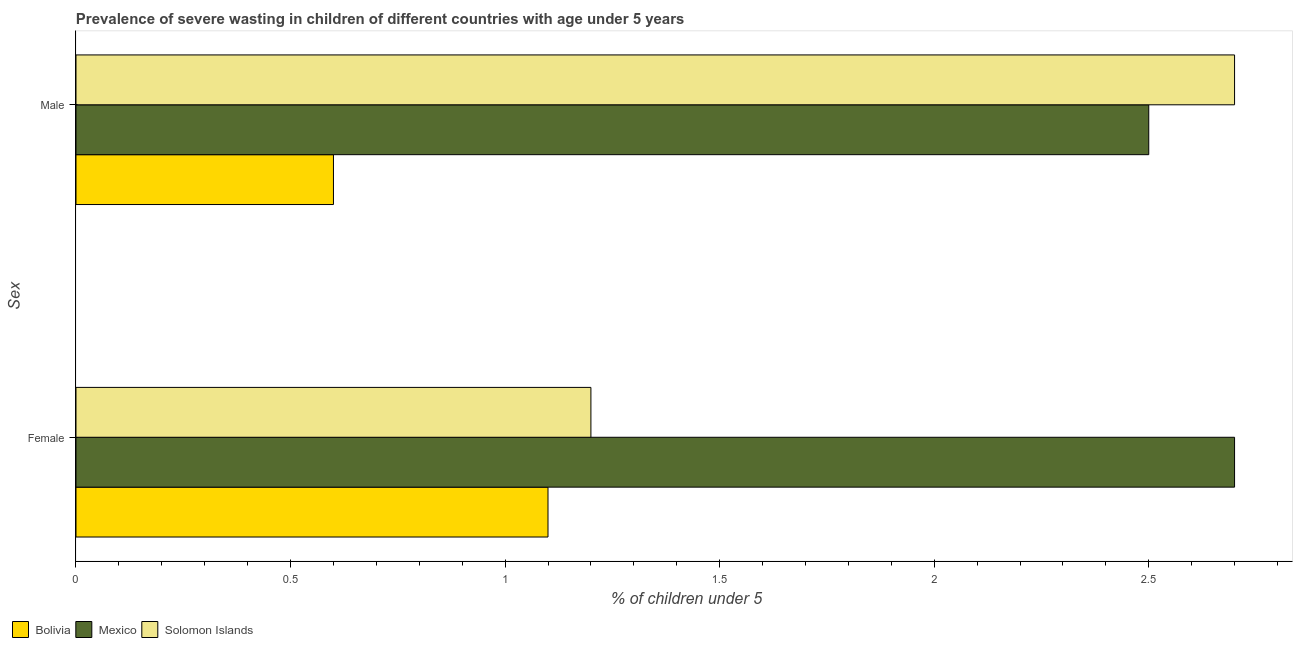Are the number of bars on each tick of the Y-axis equal?
Offer a terse response. Yes. How many bars are there on the 2nd tick from the bottom?
Make the answer very short. 3. What is the label of the 1st group of bars from the top?
Your answer should be compact. Male. Across all countries, what is the maximum percentage of undernourished female children?
Make the answer very short. 2.7. Across all countries, what is the minimum percentage of undernourished male children?
Your response must be concise. 0.6. In which country was the percentage of undernourished female children maximum?
Your answer should be very brief. Mexico. In which country was the percentage of undernourished female children minimum?
Offer a very short reply. Bolivia. What is the total percentage of undernourished male children in the graph?
Provide a short and direct response. 5.8. What is the difference between the percentage of undernourished male children in Bolivia and that in Solomon Islands?
Offer a very short reply. -2.1. What is the difference between the percentage of undernourished female children in Solomon Islands and the percentage of undernourished male children in Mexico?
Offer a very short reply. -1.3. What is the average percentage of undernourished female children per country?
Your response must be concise. 1.67. What is the difference between the percentage of undernourished female children and percentage of undernourished male children in Solomon Islands?
Your answer should be compact. -1.5. What is the ratio of the percentage of undernourished female children in Bolivia to that in Solomon Islands?
Your answer should be very brief. 0.92. Is the percentage of undernourished female children in Mexico less than that in Solomon Islands?
Your answer should be compact. No. In how many countries, is the percentage of undernourished female children greater than the average percentage of undernourished female children taken over all countries?
Your answer should be compact. 1. What does the 2nd bar from the bottom in Female represents?
Make the answer very short. Mexico. How many bars are there?
Your answer should be compact. 6. How many countries are there in the graph?
Make the answer very short. 3. What is the difference between two consecutive major ticks on the X-axis?
Provide a short and direct response. 0.5. Does the graph contain any zero values?
Provide a short and direct response. No. Where does the legend appear in the graph?
Offer a terse response. Bottom left. How many legend labels are there?
Your answer should be very brief. 3. What is the title of the graph?
Provide a short and direct response. Prevalence of severe wasting in children of different countries with age under 5 years. What is the label or title of the X-axis?
Keep it short and to the point.  % of children under 5. What is the label or title of the Y-axis?
Offer a terse response. Sex. What is the  % of children under 5 in Bolivia in Female?
Make the answer very short. 1.1. What is the  % of children under 5 of Mexico in Female?
Provide a succinct answer. 2.7. What is the  % of children under 5 in Solomon Islands in Female?
Ensure brevity in your answer.  1.2. What is the  % of children under 5 in Bolivia in Male?
Keep it short and to the point. 0.6. What is the  % of children under 5 in Solomon Islands in Male?
Give a very brief answer. 2.7. Across all Sex, what is the maximum  % of children under 5 in Bolivia?
Offer a terse response. 1.1. Across all Sex, what is the maximum  % of children under 5 in Mexico?
Keep it short and to the point. 2.7. Across all Sex, what is the maximum  % of children under 5 in Solomon Islands?
Make the answer very short. 2.7. Across all Sex, what is the minimum  % of children under 5 in Bolivia?
Provide a succinct answer. 0.6. Across all Sex, what is the minimum  % of children under 5 of Solomon Islands?
Give a very brief answer. 1.2. What is the total  % of children under 5 of Mexico in the graph?
Your answer should be very brief. 5.2. What is the difference between the  % of children under 5 in Bolivia in Female and that in Male?
Make the answer very short. 0.5. What is the difference between the  % of children under 5 of Mexico in Female and that in Male?
Give a very brief answer. 0.2. What is the difference between the  % of children under 5 of Solomon Islands in Female and that in Male?
Make the answer very short. -1.5. What is the difference between the  % of children under 5 of Bolivia in Female and the  % of children under 5 of Mexico in Male?
Provide a short and direct response. -1.4. What is the average  % of children under 5 in Bolivia per Sex?
Your answer should be compact. 0.85. What is the average  % of children under 5 of Solomon Islands per Sex?
Offer a terse response. 1.95. What is the difference between the  % of children under 5 in Bolivia and  % of children under 5 in Mexico in Female?
Offer a terse response. -1.6. What is the difference between the  % of children under 5 in Bolivia and  % of children under 5 in Mexico in Male?
Provide a short and direct response. -1.9. What is the difference between the  % of children under 5 in Bolivia and  % of children under 5 in Solomon Islands in Male?
Provide a short and direct response. -2.1. What is the ratio of the  % of children under 5 of Bolivia in Female to that in Male?
Your answer should be very brief. 1.83. What is the ratio of the  % of children under 5 of Solomon Islands in Female to that in Male?
Make the answer very short. 0.44. What is the difference between the highest and the second highest  % of children under 5 of Bolivia?
Offer a very short reply. 0.5. What is the difference between the highest and the second highest  % of children under 5 of Solomon Islands?
Keep it short and to the point. 1.5. What is the difference between the highest and the lowest  % of children under 5 in Bolivia?
Keep it short and to the point. 0.5. 